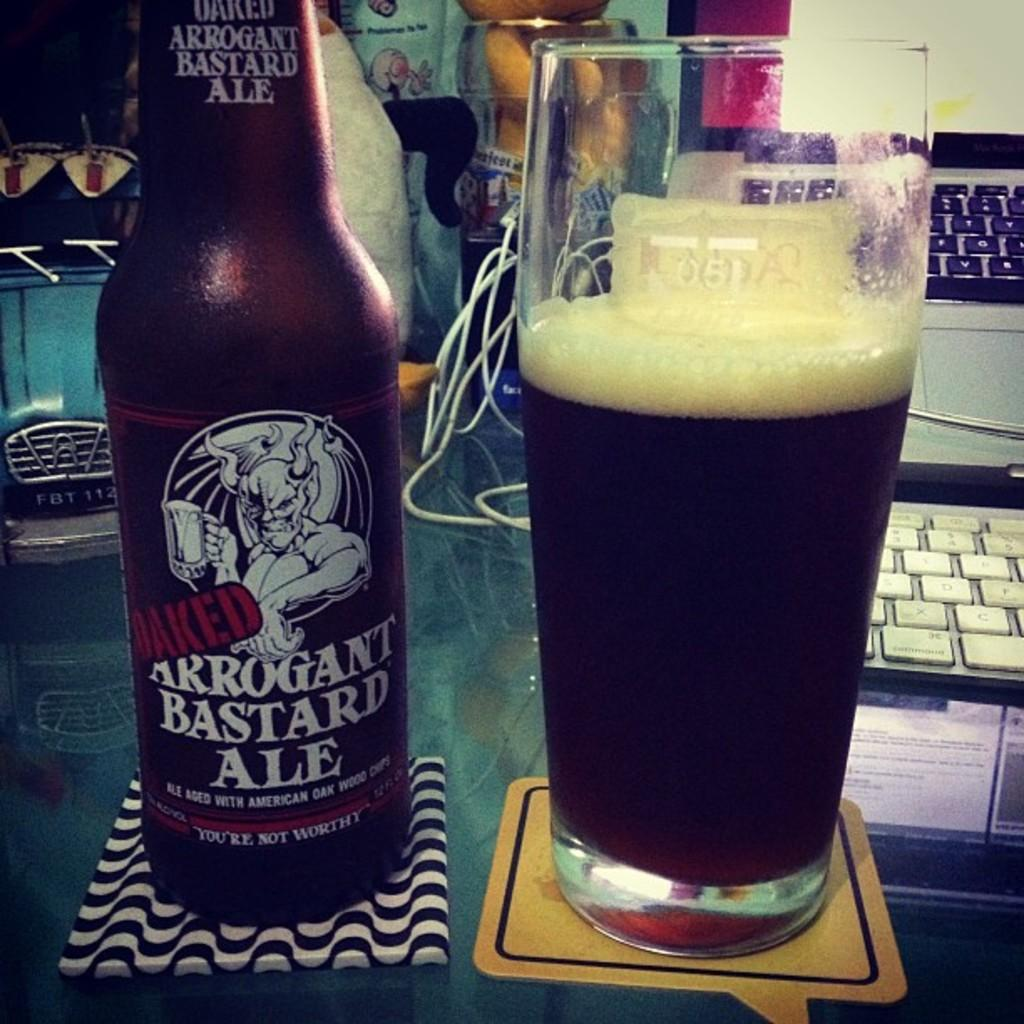<image>
Share a concise interpretation of the image provided. Glass of Baked Arrogant Bastard Ale with bottle in front of a keyboard. 